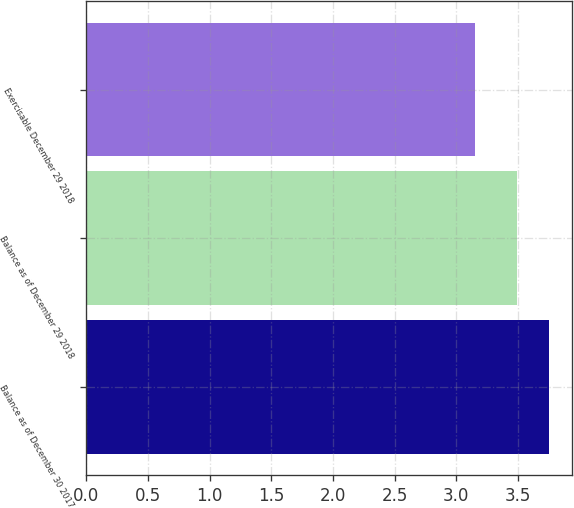Convert chart to OTSL. <chart><loc_0><loc_0><loc_500><loc_500><bar_chart><fcel>Balance as of December 30 2017<fcel>Balance as of December 29 2018<fcel>Exercisable December 29 2018<nl><fcel>3.75<fcel>3.49<fcel>3.15<nl></chart> 